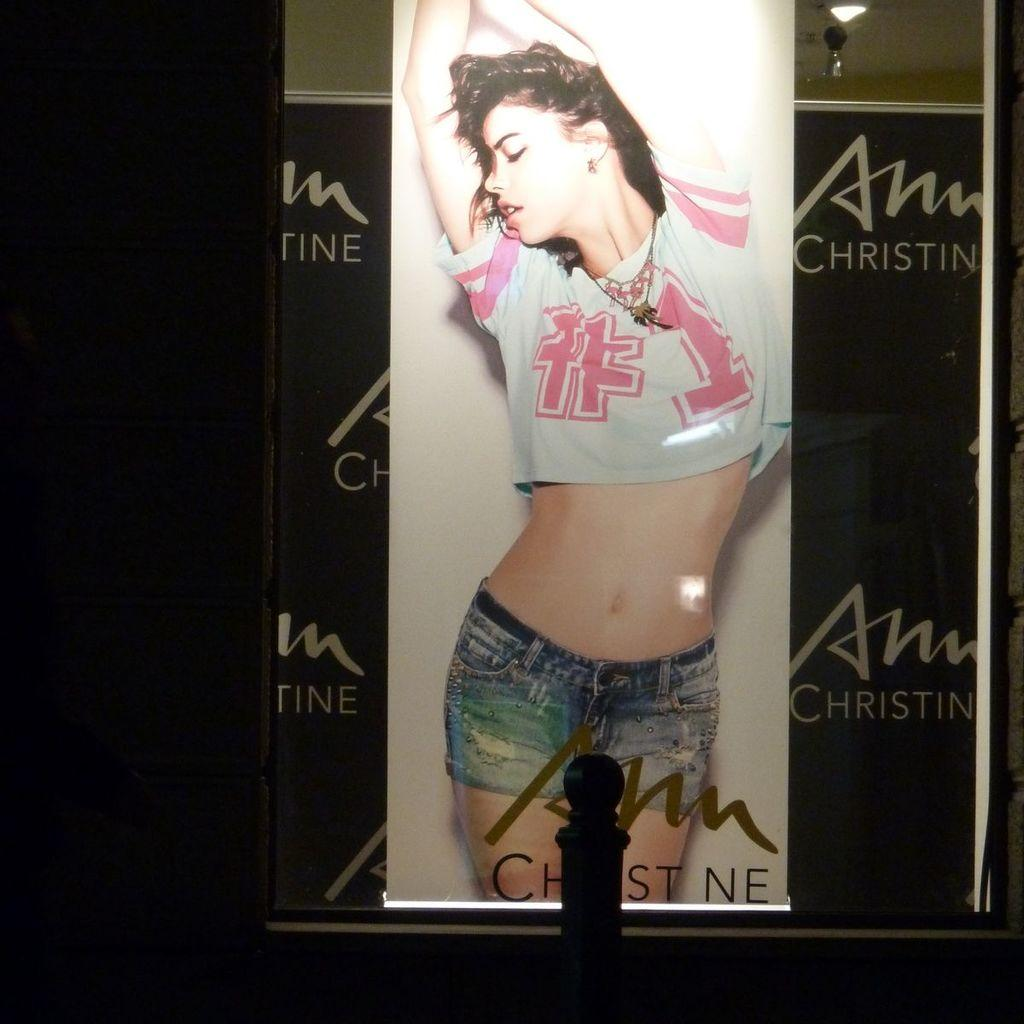<image>
Offer a succinct explanation of the picture presented. A large backlit ad for Ann Christine shows a young woman with bare midriff. 